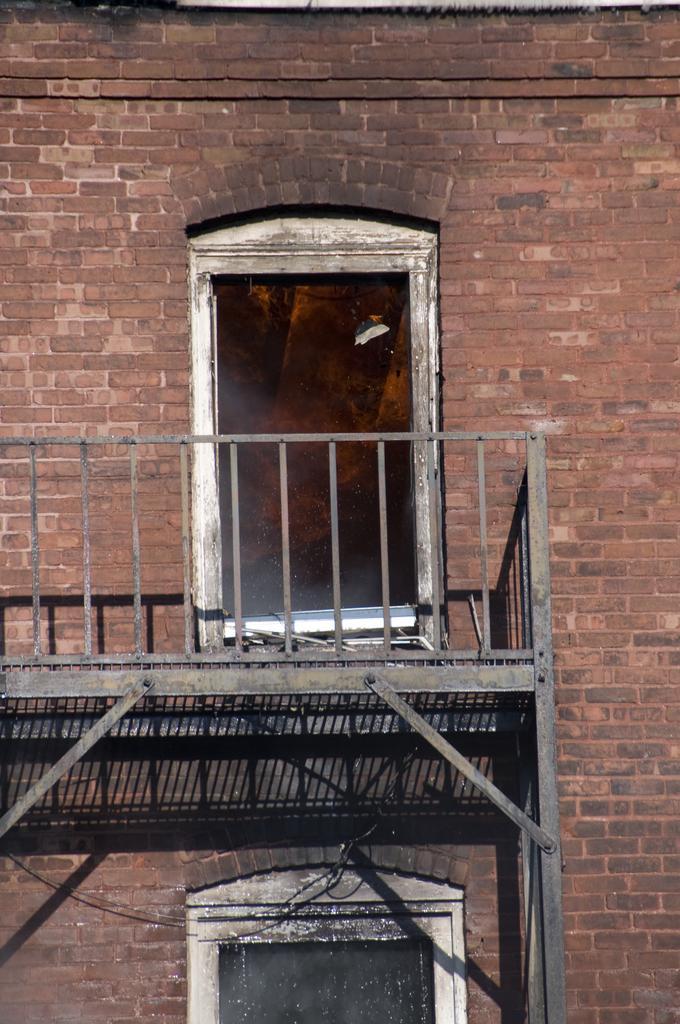Can you describe this image briefly? In this image we can see a window, fencing and we can also see a brick wall. 